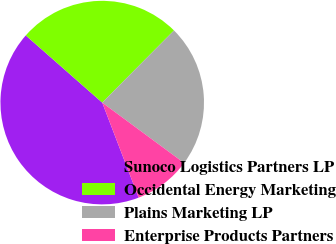Convert chart. <chart><loc_0><loc_0><loc_500><loc_500><pie_chart><fcel>Sunoco Logistics Partners LP<fcel>Occidental Energy Marketing<fcel>Plains Marketing LP<fcel>Enterprise Products Partners<nl><fcel>42.3%<fcel>25.98%<fcel>22.66%<fcel>9.06%<nl></chart> 